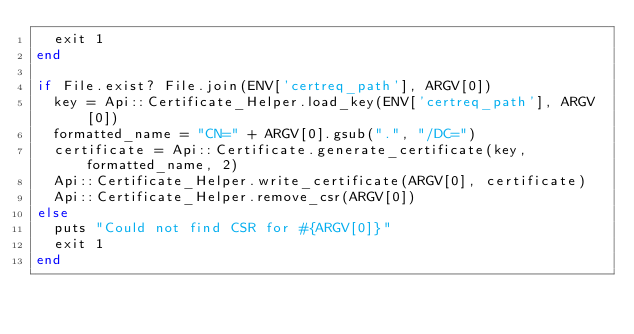<code> <loc_0><loc_0><loc_500><loc_500><_Ruby_>  exit 1
end

if File.exist? File.join(ENV['certreq_path'], ARGV[0])
  key = Api::Certificate_Helper.load_key(ENV['certreq_path'], ARGV[0])
  formatted_name = "CN=" + ARGV[0].gsub(".", "/DC=")
  certificate = Api::Certificate.generate_certificate(key, formatted_name, 2)
  Api::Certificate_Helper.write_certificate(ARGV[0], certificate)
  Api::Certificate_Helper.remove_csr(ARGV[0])
else
  puts "Could not find CSR for #{ARGV[0]}"
  exit 1
end
</code> 